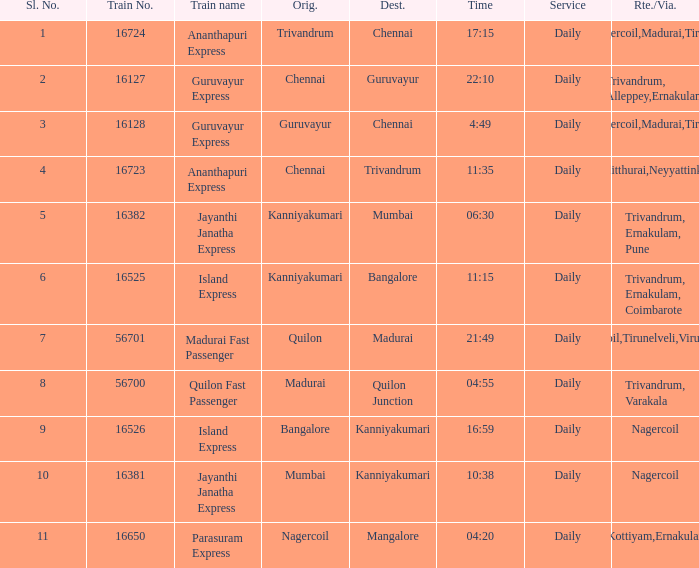What is the route/via when the destination is listed as Madurai? Nagercoil,Tirunelveli,Virudunagar. 